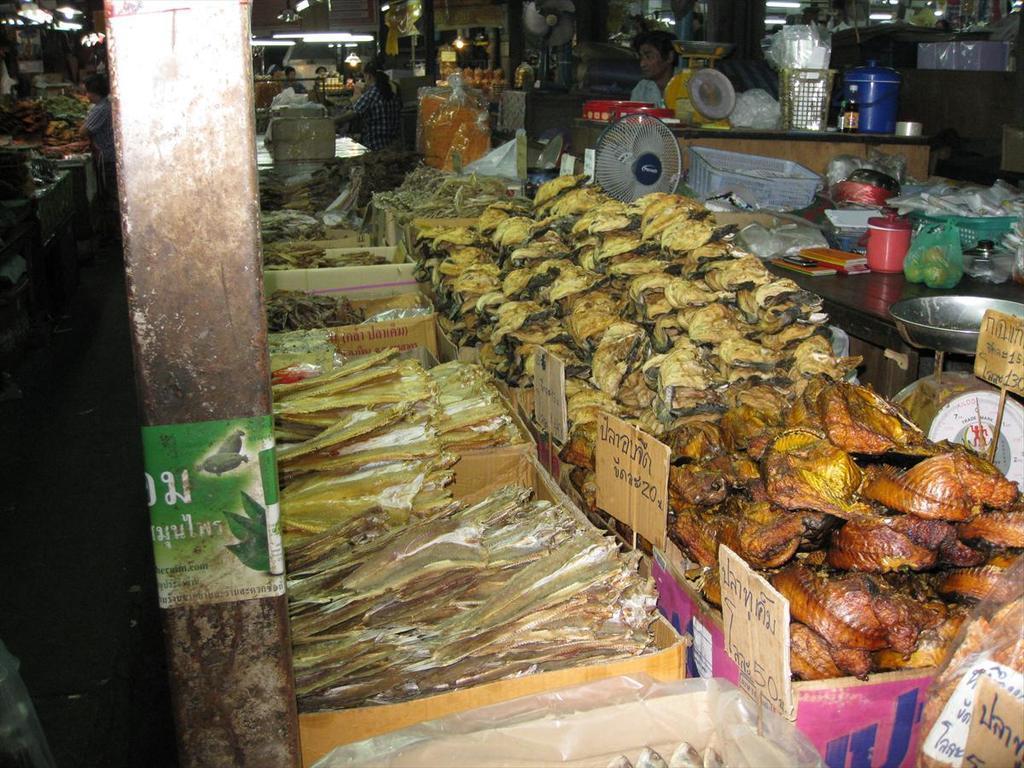In one or two sentences, can you explain what this image depicts? In this image, we can see sea food in the boxes and there are boards, containers, baskets, buckets, lights,some people, a table fan and there are some other food items and some objects, stands and we can see a poster with some text is on the pillar. 